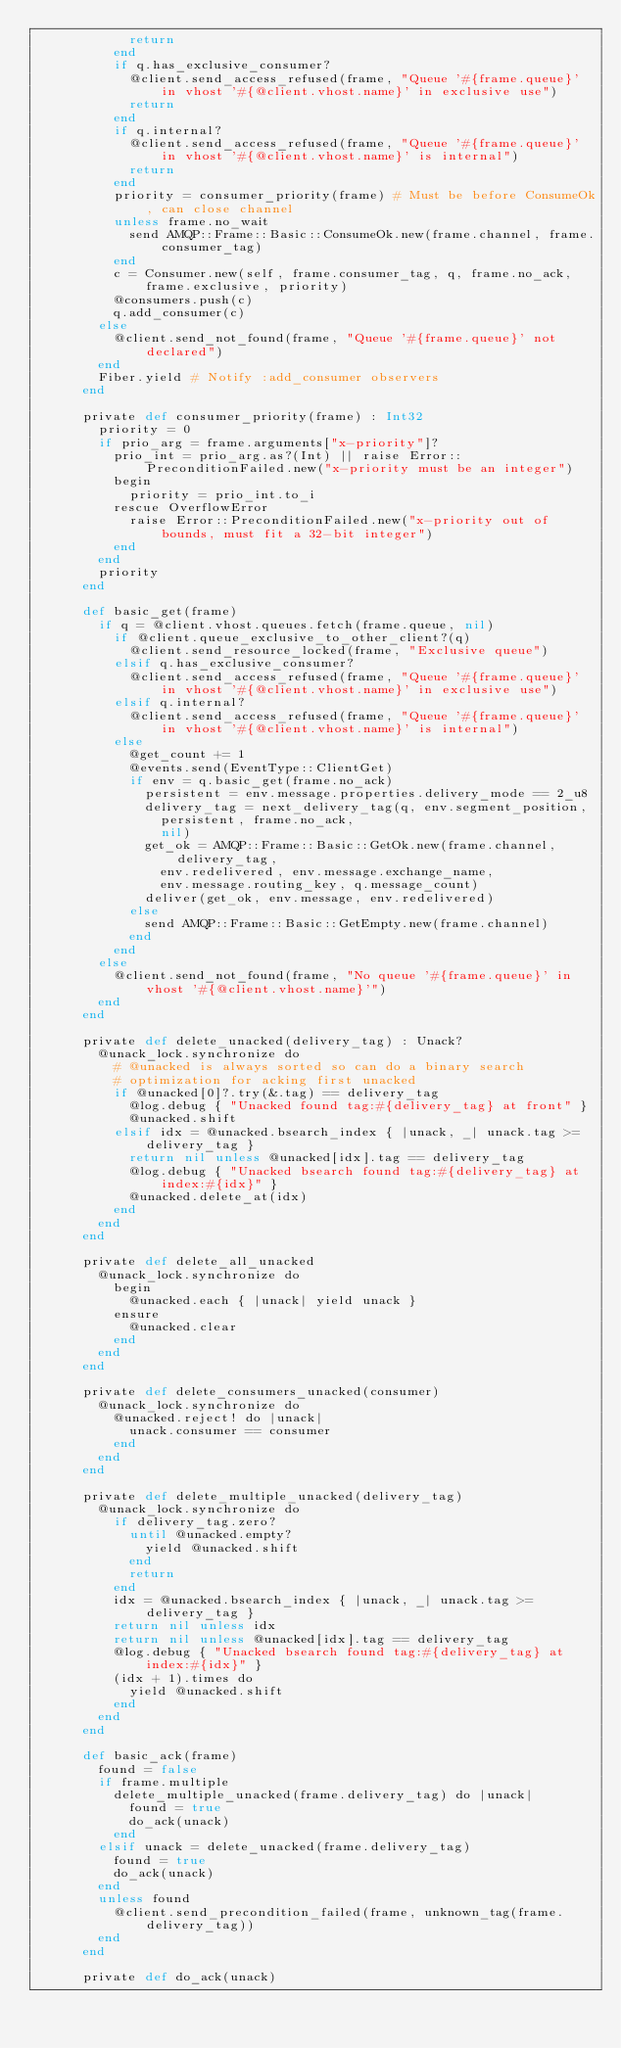Convert code to text. <code><loc_0><loc_0><loc_500><loc_500><_Crystal_>            return
          end
          if q.has_exclusive_consumer?
            @client.send_access_refused(frame, "Queue '#{frame.queue}' in vhost '#{@client.vhost.name}' in exclusive use")
            return
          end
          if q.internal?
            @client.send_access_refused(frame, "Queue '#{frame.queue}' in vhost '#{@client.vhost.name}' is internal")
            return
          end
          priority = consumer_priority(frame) # Must be before ConsumeOk, can close channel
          unless frame.no_wait
            send AMQP::Frame::Basic::ConsumeOk.new(frame.channel, frame.consumer_tag)
          end
          c = Consumer.new(self, frame.consumer_tag, q, frame.no_ack, frame.exclusive, priority)
          @consumers.push(c)
          q.add_consumer(c)
        else
          @client.send_not_found(frame, "Queue '#{frame.queue}' not declared")
        end
        Fiber.yield # Notify :add_consumer observers
      end

      private def consumer_priority(frame) : Int32
        priority = 0
        if prio_arg = frame.arguments["x-priority"]?
          prio_int = prio_arg.as?(Int) || raise Error::PreconditionFailed.new("x-priority must be an integer")
          begin
            priority = prio_int.to_i
          rescue OverflowError
            raise Error::PreconditionFailed.new("x-priority out of bounds, must fit a 32-bit integer")
          end
        end
        priority
      end

      def basic_get(frame)
        if q = @client.vhost.queues.fetch(frame.queue, nil)
          if @client.queue_exclusive_to_other_client?(q)
            @client.send_resource_locked(frame, "Exclusive queue")
          elsif q.has_exclusive_consumer?
            @client.send_access_refused(frame, "Queue '#{frame.queue}' in vhost '#{@client.vhost.name}' in exclusive use")
          elsif q.internal?
            @client.send_access_refused(frame, "Queue '#{frame.queue}' in vhost '#{@client.vhost.name}' is internal")
          else
            @get_count += 1
            @events.send(EventType::ClientGet)
            if env = q.basic_get(frame.no_ack)
              persistent = env.message.properties.delivery_mode == 2_u8
              delivery_tag = next_delivery_tag(q, env.segment_position,
                persistent, frame.no_ack,
                nil)
              get_ok = AMQP::Frame::Basic::GetOk.new(frame.channel, delivery_tag,
                env.redelivered, env.message.exchange_name,
                env.message.routing_key, q.message_count)
              deliver(get_ok, env.message, env.redelivered)
            else
              send AMQP::Frame::Basic::GetEmpty.new(frame.channel)
            end
          end
        else
          @client.send_not_found(frame, "No queue '#{frame.queue}' in vhost '#{@client.vhost.name}'")
        end
      end

      private def delete_unacked(delivery_tag) : Unack?
        @unack_lock.synchronize do
          # @unacked is always sorted so can do a binary search
          # optimization for acking first unacked
          if @unacked[0]?.try(&.tag) == delivery_tag
            @log.debug { "Unacked found tag:#{delivery_tag} at front" }
            @unacked.shift
          elsif idx = @unacked.bsearch_index { |unack, _| unack.tag >= delivery_tag }
            return nil unless @unacked[idx].tag == delivery_tag
            @log.debug { "Unacked bsearch found tag:#{delivery_tag} at index:#{idx}" }
            @unacked.delete_at(idx)
          end
        end
      end

      private def delete_all_unacked
        @unack_lock.synchronize do
          begin
            @unacked.each { |unack| yield unack }
          ensure
            @unacked.clear
          end
        end
      end

      private def delete_consumers_unacked(consumer)
        @unack_lock.synchronize do
          @unacked.reject! do |unack|
            unack.consumer == consumer
          end
        end
      end

      private def delete_multiple_unacked(delivery_tag)
        @unack_lock.synchronize do
          if delivery_tag.zero?
            until @unacked.empty?
              yield @unacked.shift
            end
            return
          end
          idx = @unacked.bsearch_index { |unack, _| unack.tag >= delivery_tag }
          return nil unless idx
          return nil unless @unacked[idx].tag == delivery_tag
          @log.debug { "Unacked bsearch found tag:#{delivery_tag} at index:#{idx}" }
          (idx + 1).times do
            yield @unacked.shift
          end
        end
      end

      def basic_ack(frame)
        found = false
        if frame.multiple
          delete_multiple_unacked(frame.delivery_tag) do |unack|
            found = true
            do_ack(unack)
          end
        elsif unack = delete_unacked(frame.delivery_tag)
          found = true
          do_ack(unack)
        end
        unless found
          @client.send_precondition_failed(frame, unknown_tag(frame.delivery_tag))
        end
      end

      private def do_ack(unack)</code> 